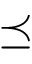<formula> <loc_0><loc_0><loc_500><loc_500>\preceq</formula> 